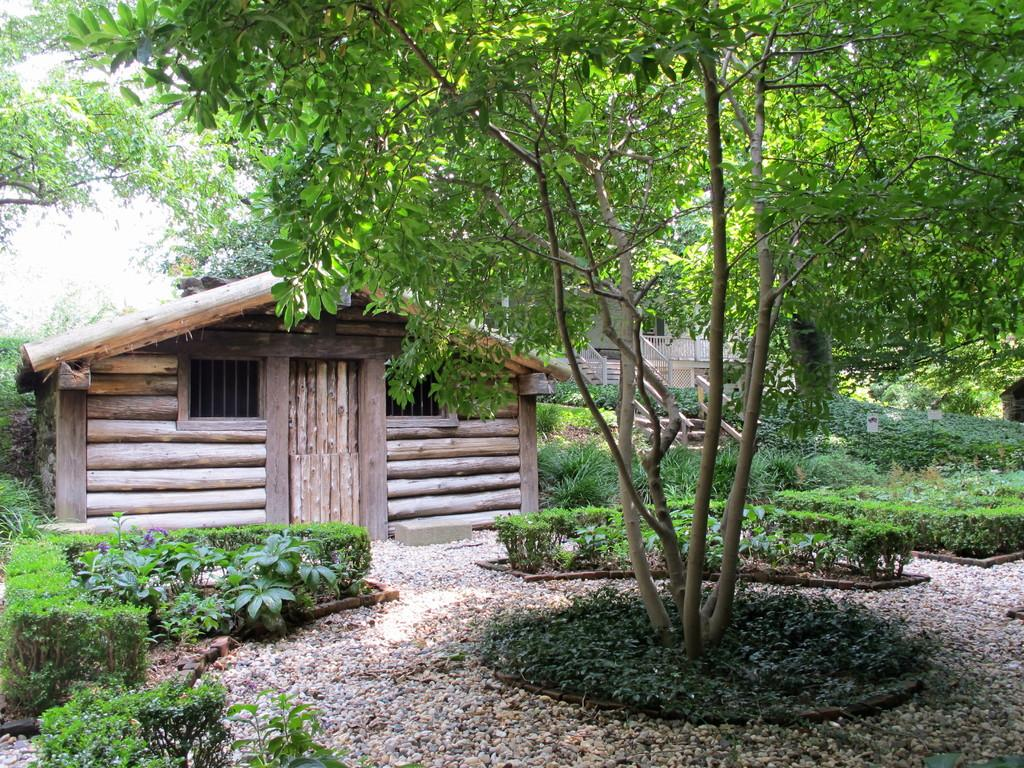How many houses can be seen in the image? There are two houses in the image. What architectural feature is present in the houses? There are staircases in the image. What type of natural elements are visible in the image? There are many trees and plants in the image. Can you tell me how many basketballs are hanging from the trees in the image? There are no basketballs present in the image; it features trees and plants. What type of monkey can be seen climbing the staircase in the image? There are no monkeys present in the image; it features houses, staircases, trees, and plants. 